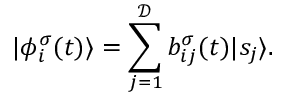Convert formula to latex. <formula><loc_0><loc_0><loc_500><loc_500>| \phi _ { i } ^ { \sigma } ( t ) \rangle = \sum _ { j = 1 } ^ { \mathcal { D } } b _ { i j } ^ { \sigma } ( t ) | s _ { j } \rangle .</formula> 